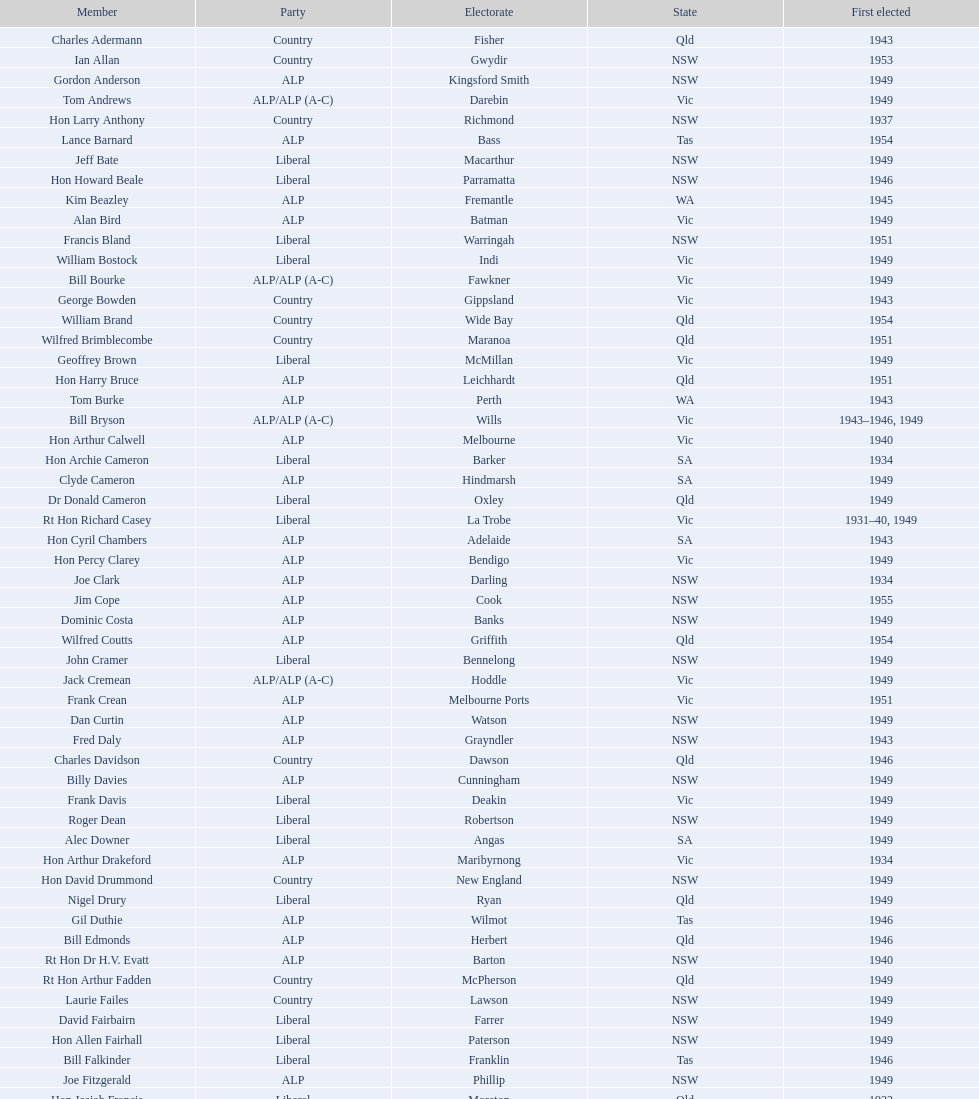What is the number of alp party members elected? 57. 